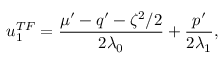Convert formula to latex. <formula><loc_0><loc_0><loc_500><loc_500>u _ { 1 } ^ { T F } = \frac { \mu ^ { \prime } - q ^ { \prime } - \zeta ^ { 2 } / 2 } { 2 \lambda _ { 0 } } + \frac { p ^ { \prime } } { 2 \lambda _ { 1 } } ,</formula> 